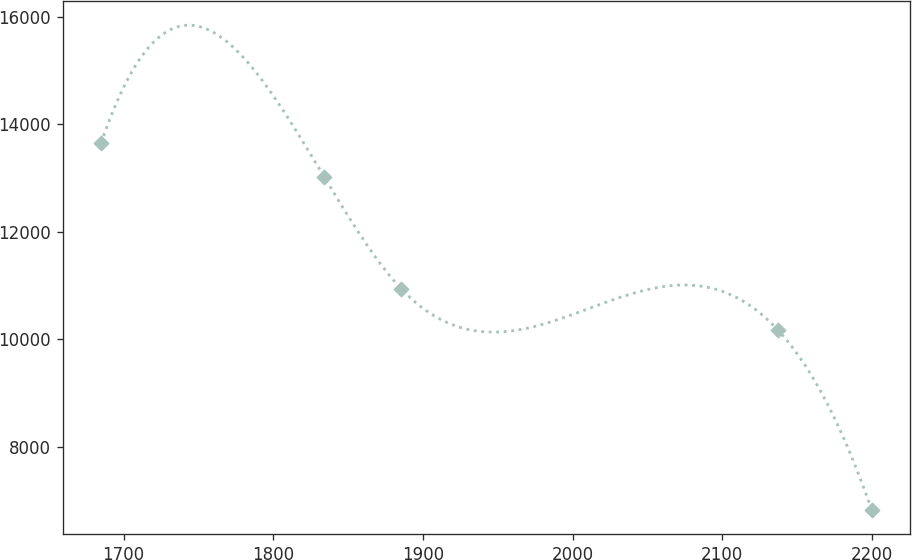<chart> <loc_0><loc_0><loc_500><loc_500><line_chart><ecel><fcel>Unnamed: 1<nl><fcel>1684.91<fcel>13653.8<nl><fcel>1834.14<fcel>13017.7<nl><fcel>1885.64<fcel>10935.7<nl><fcel>2137.08<fcel>10177.2<nl><fcel>2199.92<fcel>6822.74<nl></chart> 